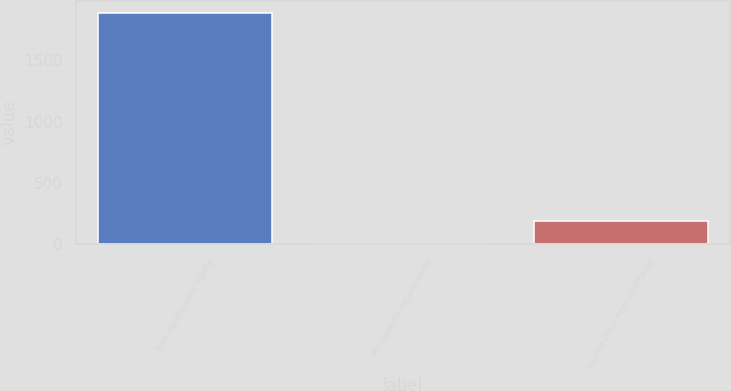Convert chart. <chart><loc_0><loc_0><loc_500><loc_500><bar_chart><fcel>Total stockholders' equity<fcel>Provision for income taxes<fcel>Income (loss) from continuing<nl><fcel>1886.7<fcel>5<fcel>193.17<nl></chart> 